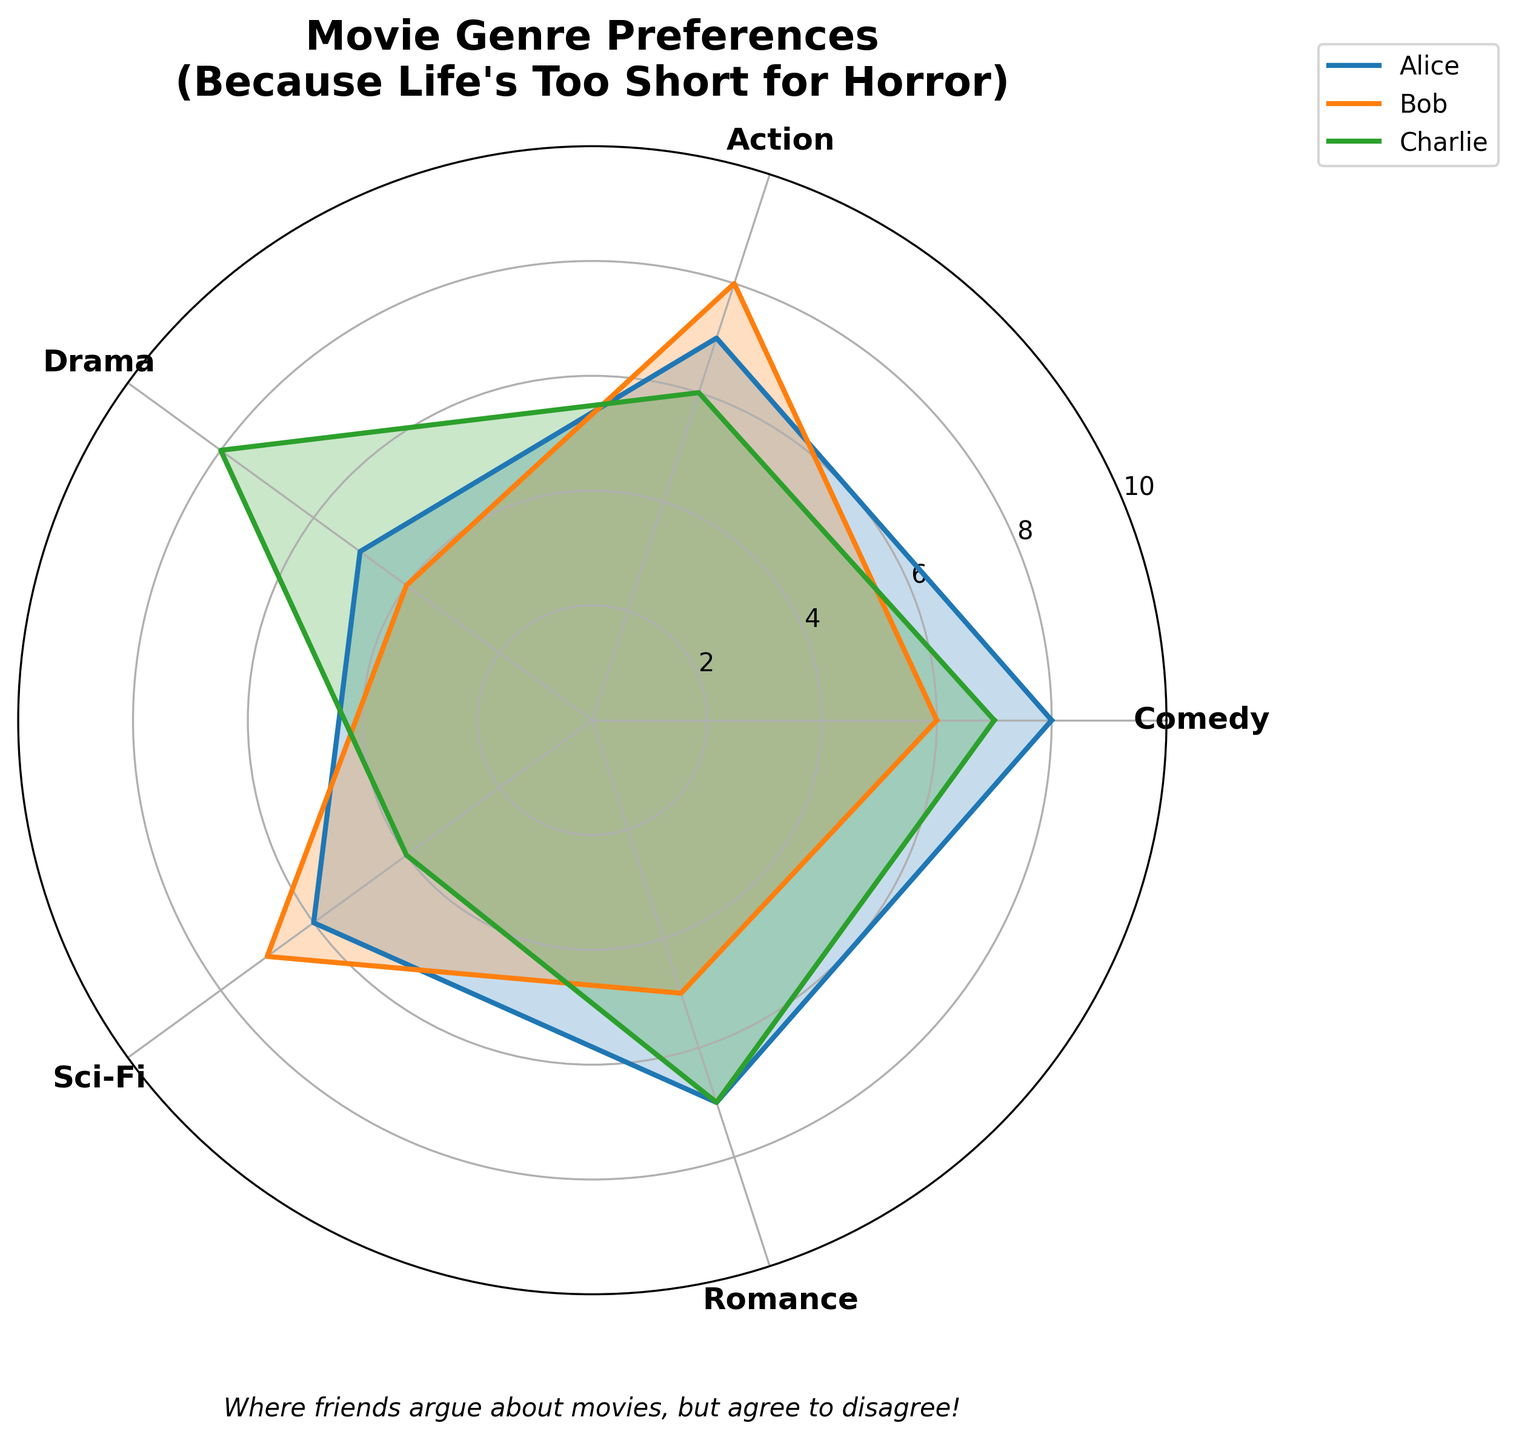What are the five genres displayed in the chart? The genres are listed as categories around the radar chart. By reading the labels, you can identify the genres.
Answer: Comedy, Action, Drama, Sci-Fi, Romance Which friend has the highest preference for Sci-Fi movies? The Sci-Fi label is one of the axes in the radar chart. By looking at which friend's plot is closest to the outermost circle (highest value) on that axis, you can determine the highest preference.
Answer: Bob What is Alice's average rating across all genres? To calculate Alice's average rating, sum her ratings for all genres and then divide by the number of genres: (8 + 7 + 5 + 6 + 7) / 5 = 33 / 5 = 6.6.
Answer: 6.6 Who prefers Drama movies the most? Look at the Drama axis on the radar chart and see which friend's plot is closest to the outermost circle on that axis.
Answer: Charlie How do Charlie's preferences for Comedy and Action compare? Examine the values for Charlie on the Comedy and Action axes. Comedy is at 7 and Action is at 6. Comedy is higher.
Answer: Charlie prefers Comedy more than Action On average, which genre has the lowest rating among all friends? Calculate the average rating for each genre across all friends:  
Comedy: (8 + 6 + 7)/3 = 7  
Action: (7 + 8 + 6)/3 = 7  
Drama: (5 + 4 + 8)/3 = 5.67  
Sci-Fi: (6 + 7 + 4)/3 = 5.67  
Romance: (7 + 5 + 7)/3 = 6.33  
The lowest average rating is for Drama and Sci-Fi.
Answer: Drama and Sci-Fi Which friend has the most varied taste in movie genres? The friend with the most varied taste will have the highest standard deviation in their ratings. Calculating this:  
Alice: std = sqrt(((8−6.6)^2 + (7−6.6)^2 + (5−6.6)^2 + (6−6.6)^2 + (7−6.6)^2)/5) = 1.14  
Bob: std = sqrt(((6−6)^2 + (8−6)^2 + (4−6)^2 + (7−6)^2 + (5−6)^2)/5) = 1.41  
Charlie: std = sqrt(((7−6.4)^2 + (6−6.4)^2 + (8−6.4)^2 + (4−6.4)^2 + (7−6.4)^2)/5) = 1.52  
Charlie has the highest standard deviation.
Answer: Charlie Which genre does Bob have the lowest preference for? Look at Bob's values and identify the lowest one. Bob's ratings are Comedy: 6, Action: 8, Drama: 4, Sci-Fi: 7, Romance: 5. The lowest is for Drama.
Answer: Drama If a movie night is organized based on a genre liked by all but excluding the highest preference of each friend, which genre is likely to be the best choice? Exclude the highest preference of each friend (Alice: Comedy, Bob: Action, Charlie: Drama).	Check the remaining ratings:  
Alice: 5, 6, 7  
Bob: 6, 4, 7, 5  
Charlie: 8, 4, 7  
The ratings left show Sci-Fi is a common and relatively liked genre among the remaining choices.
Answer: Sci-Fi 